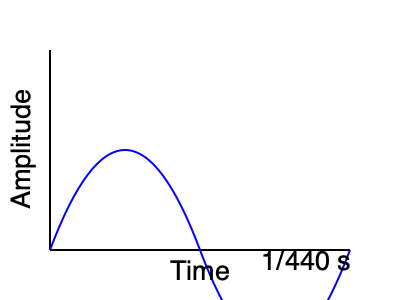The graph shows a sound wave produced by a violin. If this wave represents the note A4 (concert pitch), what is the frequency of this note in Hertz (Hz)? To find the frequency of the note, we need to follow these steps:

1. Recall that frequency is the number of cycles per second.
2. From the graph, we can see that one complete cycle (wavelength) occurs in 1/440 seconds.
3. To calculate the frequency, we need to determine how many of these cycles occur in one second.
4. We can set up the following equation:

   $$ \text{Frequency} = \frac{\text{Number of cycles}}{\text{Time}} $$

5. In this case, we have 1 cycle in 1/440 seconds. To find the number of cycles in 1 second:

   $$ \text{Frequency} = \frac{1 \text{ cycle}}{1/440 \text{ second}} = 440 \text{ Hz} $$

6. Therefore, the frequency of this note is 440 Hz.

This frequency corresponds to the standard concert pitch A4, which is indeed 440 Hz. This is the note that orchestras typically tune to before a performance.
Answer: 440 Hz 